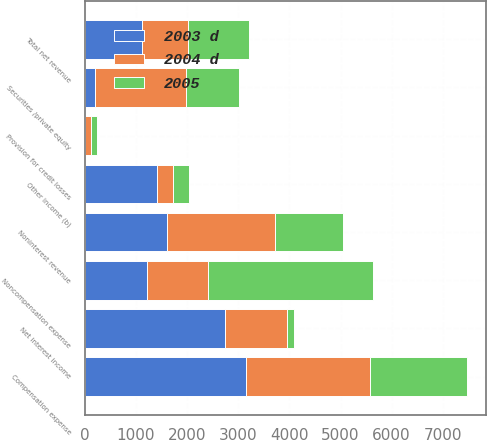<chart> <loc_0><loc_0><loc_500><loc_500><stacked_bar_chart><ecel><fcel>Securities /private equity<fcel>Other income (b)<fcel>Noninterest revenue<fcel>Net interest income<fcel>Total net revenue<fcel>Provision for credit losses<fcel>Compensation expense<fcel>Noncompensation expense<nl><fcel>2003 d<fcel>200<fcel>1410<fcel>1610<fcel>2736<fcel>1126<fcel>10<fcel>3151<fcel>1208.5<nl><fcel>2004 d<fcel>1786<fcel>315<fcel>2101<fcel>1216<fcel>885<fcel>110<fcel>2426<fcel>1208.5<nl><fcel>2005<fcel>1031<fcel>303<fcel>1334<fcel>133<fcel>1201<fcel>124<fcel>1893<fcel>3216<nl></chart> 